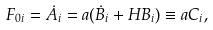<formula> <loc_0><loc_0><loc_500><loc_500>F _ { 0 i } = \dot { A } _ { i } = a ( \dot { B } _ { i } + H B _ { i } ) \equiv a C _ { i } ,</formula> 